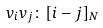<formula> <loc_0><loc_0><loc_500><loc_500>v _ { i } v _ { j } \colon [ i - j ] _ { N }</formula> 